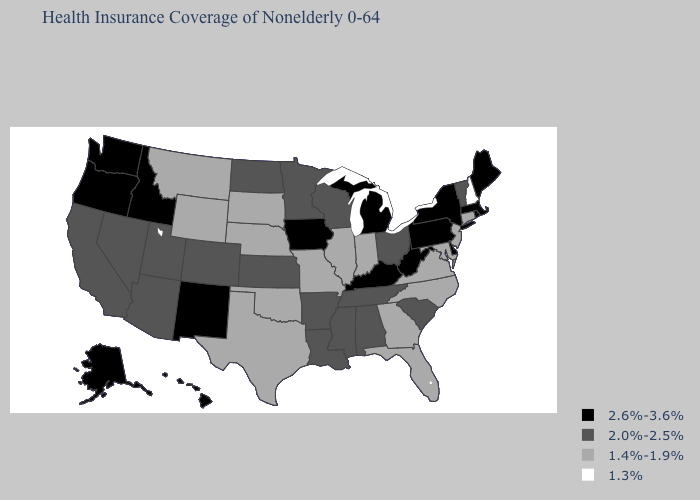Among the states that border Massachusetts , which have the lowest value?
Quick response, please. New Hampshire. Name the states that have a value in the range 2.6%-3.6%?
Keep it brief. Alaska, Delaware, Hawaii, Idaho, Iowa, Kentucky, Maine, Massachusetts, Michigan, New Mexico, New York, Oregon, Pennsylvania, Rhode Island, Washington, West Virginia. Among the states that border Illinois , which have the highest value?
Answer briefly. Iowa, Kentucky. Name the states that have a value in the range 2.0%-2.5%?
Quick response, please. Alabama, Arizona, Arkansas, California, Colorado, Kansas, Louisiana, Minnesota, Mississippi, Nevada, North Dakota, Ohio, South Carolina, Tennessee, Utah, Vermont, Wisconsin. Which states have the lowest value in the Northeast?
Write a very short answer. New Hampshire. How many symbols are there in the legend?
Write a very short answer. 4. Does West Virginia have a higher value than Connecticut?
Write a very short answer. Yes. Does Oregon have the highest value in the USA?
Quick response, please. Yes. Which states have the highest value in the USA?
Quick response, please. Alaska, Delaware, Hawaii, Idaho, Iowa, Kentucky, Maine, Massachusetts, Michigan, New Mexico, New York, Oregon, Pennsylvania, Rhode Island, Washington, West Virginia. Among the states that border Maryland , does Pennsylvania have the highest value?
Write a very short answer. Yes. Name the states that have a value in the range 2.6%-3.6%?
Answer briefly. Alaska, Delaware, Hawaii, Idaho, Iowa, Kentucky, Maine, Massachusetts, Michigan, New Mexico, New York, Oregon, Pennsylvania, Rhode Island, Washington, West Virginia. How many symbols are there in the legend?
Keep it brief. 4. What is the value of Idaho?
Be succinct. 2.6%-3.6%. Name the states that have a value in the range 2.0%-2.5%?
Short answer required. Alabama, Arizona, Arkansas, California, Colorado, Kansas, Louisiana, Minnesota, Mississippi, Nevada, North Dakota, Ohio, South Carolina, Tennessee, Utah, Vermont, Wisconsin. Does Montana have a higher value than New Hampshire?
Write a very short answer. Yes. 